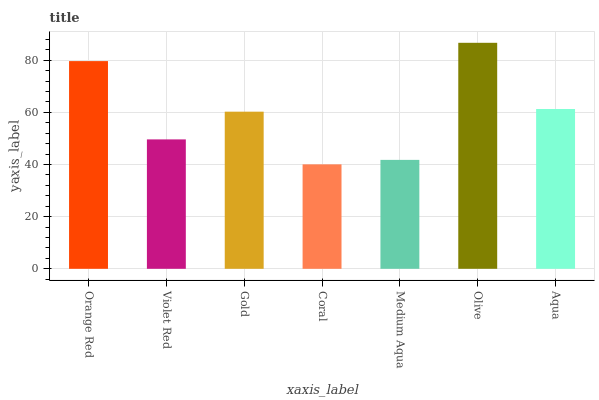Is Coral the minimum?
Answer yes or no. Yes. Is Olive the maximum?
Answer yes or no. Yes. Is Violet Red the minimum?
Answer yes or no. No. Is Violet Red the maximum?
Answer yes or no. No. Is Orange Red greater than Violet Red?
Answer yes or no. Yes. Is Violet Red less than Orange Red?
Answer yes or no. Yes. Is Violet Red greater than Orange Red?
Answer yes or no. No. Is Orange Red less than Violet Red?
Answer yes or no. No. Is Gold the high median?
Answer yes or no. Yes. Is Gold the low median?
Answer yes or no. Yes. Is Medium Aqua the high median?
Answer yes or no. No. Is Coral the low median?
Answer yes or no. No. 